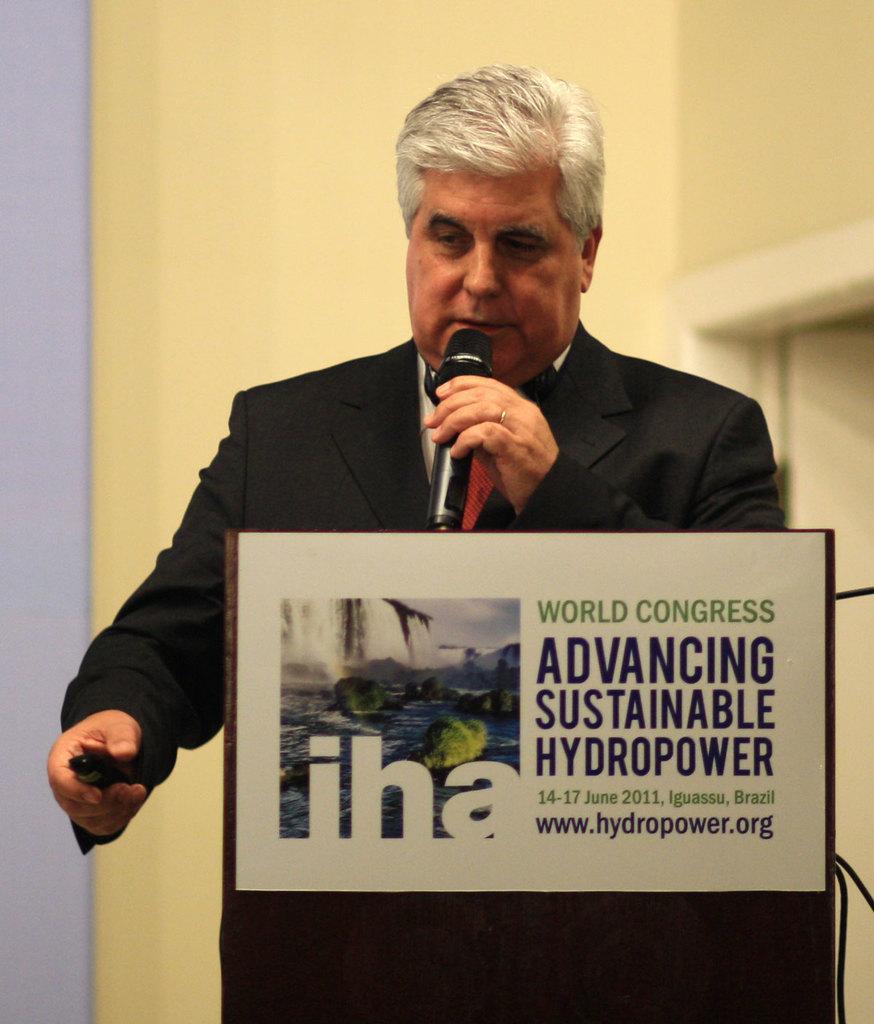In one or two sentences, can you explain what this image depicts? In a picture there is one man wearing a black dress and holding a microphone in front of the podium and a remote in his hand, on the podium there is a text written. 